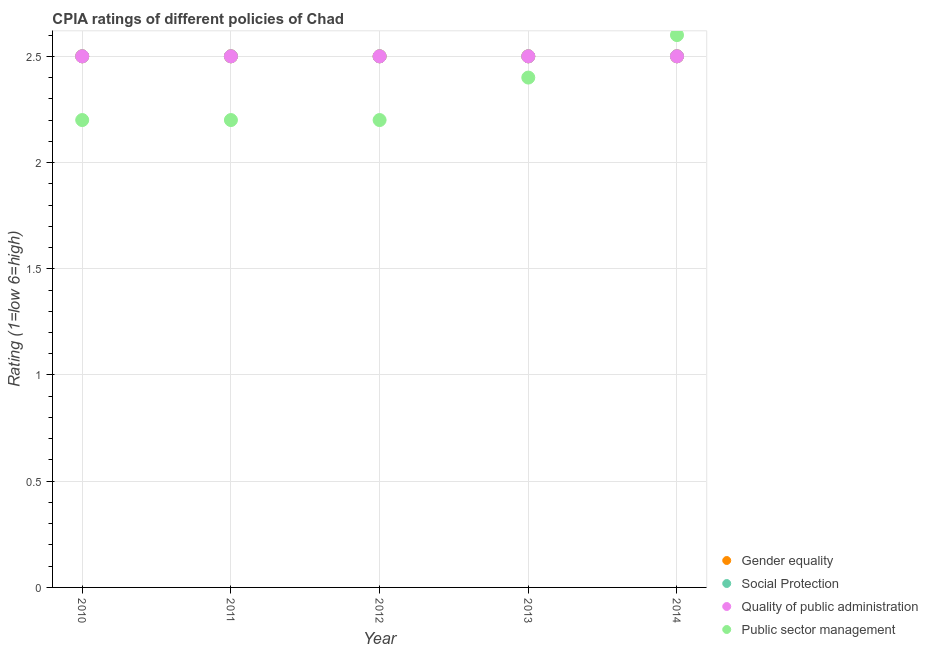How many different coloured dotlines are there?
Your response must be concise. 4. What is the cpia rating of gender equality in 2014?
Your response must be concise. 2.5. What is the total cpia rating of social protection in the graph?
Provide a short and direct response. 12.5. In how many years, is the cpia rating of gender equality greater than 1.4?
Provide a succinct answer. 5. Is the cpia rating of gender equality in 2012 less than that in 2013?
Offer a very short reply. No. Is the difference between the cpia rating of social protection in 2011 and 2013 greater than the difference between the cpia rating of quality of public administration in 2011 and 2013?
Your answer should be very brief. No. What is the difference between the highest and the lowest cpia rating of gender equality?
Offer a very short reply. 0. Is it the case that in every year, the sum of the cpia rating of quality of public administration and cpia rating of social protection is greater than the sum of cpia rating of gender equality and cpia rating of public sector management?
Your answer should be compact. No. Is the cpia rating of quality of public administration strictly greater than the cpia rating of gender equality over the years?
Your response must be concise. No. How many years are there in the graph?
Keep it short and to the point. 5. What is the difference between two consecutive major ticks on the Y-axis?
Provide a short and direct response. 0.5. Does the graph contain any zero values?
Your response must be concise. No. Does the graph contain grids?
Your answer should be very brief. Yes. Where does the legend appear in the graph?
Provide a short and direct response. Bottom right. What is the title of the graph?
Your answer should be very brief. CPIA ratings of different policies of Chad. Does "Management rating" appear as one of the legend labels in the graph?
Your answer should be very brief. No. What is the label or title of the X-axis?
Your answer should be compact. Year. What is the Rating (1=low 6=high) in Quality of public administration in 2010?
Make the answer very short. 2.5. What is the Rating (1=low 6=high) in Social Protection in 2011?
Ensure brevity in your answer.  2.5. What is the Rating (1=low 6=high) in Public sector management in 2011?
Offer a terse response. 2.2. What is the Rating (1=low 6=high) of Social Protection in 2012?
Your answer should be compact. 2.5. What is the Rating (1=low 6=high) of Public sector management in 2012?
Provide a short and direct response. 2.2. What is the Rating (1=low 6=high) of Quality of public administration in 2013?
Ensure brevity in your answer.  2.5. What is the Rating (1=low 6=high) of Public sector management in 2013?
Provide a short and direct response. 2.4. What is the Rating (1=low 6=high) in Social Protection in 2014?
Ensure brevity in your answer.  2.5. Across all years, what is the maximum Rating (1=low 6=high) in Social Protection?
Offer a terse response. 2.5. Across all years, what is the maximum Rating (1=low 6=high) in Quality of public administration?
Your response must be concise. 2.5. Across all years, what is the maximum Rating (1=low 6=high) in Public sector management?
Ensure brevity in your answer.  2.6. Across all years, what is the minimum Rating (1=low 6=high) in Public sector management?
Keep it short and to the point. 2.2. What is the total Rating (1=low 6=high) of Quality of public administration in the graph?
Provide a short and direct response. 12.5. What is the total Rating (1=low 6=high) of Public sector management in the graph?
Make the answer very short. 11.6. What is the difference between the Rating (1=low 6=high) of Gender equality in 2010 and that in 2011?
Keep it short and to the point. 0. What is the difference between the Rating (1=low 6=high) in Social Protection in 2010 and that in 2011?
Your answer should be very brief. 0. What is the difference between the Rating (1=low 6=high) of Quality of public administration in 2010 and that in 2011?
Your answer should be very brief. 0. What is the difference between the Rating (1=low 6=high) of Quality of public administration in 2010 and that in 2012?
Your answer should be compact. 0. What is the difference between the Rating (1=low 6=high) of Social Protection in 2010 and that in 2013?
Your answer should be very brief. 0. What is the difference between the Rating (1=low 6=high) in Quality of public administration in 2010 and that in 2013?
Give a very brief answer. 0. What is the difference between the Rating (1=low 6=high) of Social Protection in 2010 and that in 2014?
Offer a terse response. 0. What is the difference between the Rating (1=low 6=high) of Quality of public administration in 2010 and that in 2014?
Give a very brief answer. 0. What is the difference between the Rating (1=low 6=high) of Public sector management in 2010 and that in 2014?
Keep it short and to the point. -0.4. What is the difference between the Rating (1=low 6=high) of Gender equality in 2011 and that in 2012?
Your answer should be compact. 0. What is the difference between the Rating (1=low 6=high) of Social Protection in 2011 and that in 2012?
Offer a terse response. 0. What is the difference between the Rating (1=low 6=high) in Quality of public administration in 2011 and that in 2012?
Make the answer very short. 0. What is the difference between the Rating (1=low 6=high) of Gender equality in 2011 and that in 2013?
Your answer should be very brief. 0. What is the difference between the Rating (1=low 6=high) of Quality of public administration in 2011 and that in 2013?
Your answer should be compact. 0. What is the difference between the Rating (1=low 6=high) in Gender equality in 2011 and that in 2014?
Your answer should be compact. 0. What is the difference between the Rating (1=low 6=high) in Social Protection in 2011 and that in 2014?
Keep it short and to the point. 0. What is the difference between the Rating (1=low 6=high) of Gender equality in 2012 and that in 2013?
Keep it short and to the point. 0. What is the difference between the Rating (1=low 6=high) of Quality of public administration in 2012 and that in 2014?
Keep it short and to the point. 0. What is the difference between the Rating (1=low 6=high) of Public sector management in 2012 and that in 2014?
Offer a terse response. -0.4. What is the difference between the Rating (1=low 6=high) in Social Protection in 2013 and that in 2014?
Your response must be concise. 0. What is the difference between the Rating (1=low 6=high) in Quality of public administration in 2013 and that in 2014?
Provide a succinct answer. 0. What is the difference between the Rating (1=low 6=high) in Social Protection in 2010 and the Rating (1=low 6=high) in Quality of public administration in 2011?
Give a very brief answer. 0. What is the difference between the Rating (1=low 6=high) in Quality of public administration in 2010 and the Rating (1=low 6=high) in Public sector management in 2011?
Ensure brevity in your answer.  0.3. What is the difference between the Rating (1=low 6=high) of Gender equality in 2010 and the Rating (1=low 6=high) of Social Protection in 2012?
Give a very brief answer. 0. What is the difference between the Rating (1=low 6=high) in Social Protection in 2010 and the Rating (1=low 6=high) in Quality of public administration in 2012?
Provide a short and direct response. 0. What is the difference between the Rating (1=low 6=high) in Gender equality in 2010 and the Rating (1=low 6=high) in Social Protection in 2013?
Give a very brief answer. 0. What is the difference between the Rating (1=low 6=high) in Gender equality in 2010 and the Rating (1=low 6=high) in Quality of public administration in 2013?
Your response must be concise. 0. What is the difference between the Rating (1=low 6=high) of Social Protection in 2010 and the Rating (1=low 6=high) of Quality of public administration in 2013?
Give a very brief answer. 0. What is the difference between the Rating (1=low 6=high) in Gender equality in 2010 and the Rating (1=low 6=high) in Social Protection in 2014?
Your answer should be compact. 0. What is the difference between the Rating (1=low 6=high) of Gender equality in 2010 and the Rating (1=low 6=high) of Quality of public administration in 2014?
Your answer should be compact. 0. What is the difference between the Rating (1=low 6=high) in Social Protection in 2010 and the Rating (1=low 6=high) in Public sector management in 2014?
Offer a terse response. -0.1. What is the difference between the Rating (1=low 6=high) of Quality of public administration in 2010 and the Rating (1=low 6=high) of Public sector management in 2014?
Ensure brevity in your answer.  -0.1. What is the difference between the Rating (1=low 6=high) in Gender equality in 2011 and the Rating (1=low 6=high) in Quality of public administration in 2012?
Make the answer very short. 0. What is the difference between the Rating (1=low 6=high) in Social Protection in 2011 and the Rating (1=low 6=high) in Quality of public administration in 2012?
Offer a terse response. 0. What is the difference between the Rating (1=low 6=high) in Social Protection in 2011 and the Rating (1=low 6=high) in Public sector management in 2012?
Offer a terse response. 0.3. What is the difference between the Rating (1=low 6=high) of Quality of public administration in 2011 and the Rating (1=low 6=high) of Public sector management in 2012?
Make the answer very short. 0.3. What is the difference between the Rating (1=low 6=high) in Gender equality in 2011 and the Rating (1=low 6=high) in Quality of public administration in 2013?
Ensure brevity in your answer.  0. What is the difference between the Rating (1=low 6=high) in Gender equality in 2011 and the Rating (1=low 6=high) in Social Protection in 2014?
Make the answer very short. 0. What is the difference between the Rating (1=low 6=high) of Gender equality in 2011 and the Rating (1=low 6=high) of Quality of public administration in 2014?
Make the answer very short. 0. What is the difference between the Rating (1=low 6=high) in Social Protection in 2011 and the Rating (1=low 6=high) in Public sector management in 2014?
Ensure brevity in your answer.  -0.1. What is the difference between the Rating (1=low 6=high) of Gender equality in 2012 and the Rating (1=low 6=high) of Social Protection in 2013?
Your answer should be very brief. 0. What is the difference between the Rating (1=low 6=high) of Gender equality in 2012 and the Rating (1=low 6=high) of Quality of public administration in 2013?
Offer a terse response. 0. What is the difference between the Rating (1=low 6=high) in Social Protection in 2012 and the Rating (1=low 6=high) in Quality of public administration in 2013?
Offer a very short reply. 0. What is the difference between the Rating (1=low 6=high) of Quality of public administration in 2012 and the Rating (1=low 6=high) of Public sector management in 2013?
Offer a terse response. 0.1. What is the difference between the Rating (1=low 6=high) in Social Protection in 2012 and the Rating (1=low 6=high) in Quality of public administration in 2014?
Offer a very short reply. 0. What is the difference between the Rating (1=low 6=high) in Social Protection in 2012 and the Rating (1=low 6=high) in Public sector management in 2014?
Give a very brief answer. -0.1. What is the difference between the Rating (1=low 6=high) in Quality of public administration in 2012 and the Rating (1=low 6=high) in Public sector management in 2014?
Give a very brief answer. -0.1. What is the difference between the Rating (1=low 6=high) of Social Protection in 2013 and the Rating (1=low 6=high) of Quality of public administration in 2014?
Offer a terse response. 0. What is the average Rating (1=low 6=high) in Social Protection per year?
Make the answer very short. 2.5. What is the average Rating (1=low 6=high) in Quality of public administration per year?
Make the answer very short. 2.5. What is the average Rating (1=low 6=high) of Public sector management per year?
Offer a very short reply. 2.32. In the year 2010, what is the difference between the Rating (1=low 6=high) in Gender equality and Rating (1=low 6=high) in Quality of public administration?
Give a very brief answer. 0. In the year 2010, what is the difference between the Rating (1=low 6=high) of Gender equality and Rating (1=low 6=high) of Public sector management?
Your response must be concise. 0.3. In the year 2010, what is the difference between the Rating (1=low 6=high) in Social Protection and Rating (1=low 6=high) in Public sector management?
Give a very brief answer. 0.3. In the year 2010, what is the difference between the Rating (1=low 6=high) of Quality of public administration and Rating (1=low 6=high) of Public sector management?
Make the answer very short. 0.3. In the year 2011, what is the difference between the Rating (1=low 6=high) of Gender equality and Rating (1=low 6=high) of Social Protection?
Provide a short and direct response. 0. In the year 2011, what is the difference between the Rating (1=low 6=high) in Gender equality and Rating (1=low 6=high) in Quality of public administration?
Provide a short and direct response. 0. In the year 2011, what is the difference between the Rating (1=low 6=high) of Social Protection and Rating (1=low 6=high) of Quality of public administration?
Offer a terse response. 0. In the year 2011, what is the difference between the Rating (1=low 6=high) in Social Protection and Rating (1=low 6=high) in Public sector management?
Your answer should be very brief. 0.3. In the year 2011, what is the difference between the Rating (1=low 6=high) in Quality of public administration and Rating (1=low 6=high) in Public sector management?
Provide a succinct answer. 0.3. In the year 2012, what is the difference between the Rating (1=low 6=high) in Gender equality and Rating (1=low 6=high) in Social Protection?
Offer a very short reply. 0. In the year 2012, what is the difference between the Rating (1=low 6=high) of Gender equality and Rating (1=low 6=high) of Quality of public administration?
Provide a short and direct response. 0. In the year 2012, what is the difference between the Rating (1=low 6=high) in Social Protection and Rating (1=low 6=high) in Quality of public administration?
Keep it short and to the point. 0. In the year 2012, what is the difference between the Rating (1=low 6=high) of Social Protection and Rating (1=low 6=high) of Public sector management?
Provide a succinct answer. 0.3. In the year 2013, what is the difference between the Rating (1=low 6=high) in Gender equality and Rating (1=low 6=high) in Social Protection?
Give a very brief answer. 0. In the year 2013, what is the difference between the Rating (1=low 6=high) in Gender equality and Rating (1=low 6=high) in Quality of public administration?
Provide a short and direct response. 0. In the year 2013, what is the difference between the Rating (1=low 6=high) in Social Protection and Rating (1=low 6=high) in Public sector management?
Provide a short and direct response. 0.1. In the year 2014, what is the difference between the Rating (1=low 6=high) in Gender equality and Rating (1=low 6=high) in Quality of public administration?
Provide a short and direct response. 0. In the year 2014, what is the difference between the Rating (1=low 6=high) in Gender equality and Rating (1=low 6=high) in Public sector management?
Keep it short and to the point. -0.1. In the year 2014, what is the difference between the Rating (1=low 6=high) in Social Protection and Rating (1=low 6=high) in Public sector management?
Your answer should be compact. -0.1. In the year 2014, what is the difference between the Rating (1=low 6=high) in Quality of public administration and Rating (1=low 6=high) in Public sector management?
Your response must be concise. -0.1. What is the ratio of the Rating (1=low 6=high) of Social Protection in 2010 to that in 2012?
Provide a succinct answer. 1. What is the ratio of the Rating (1=low 6=high) of Social Protection in 2010 to that in 2013?
Provide a succinct answer. 1. What is the ratio of the Rating (1=low 6=high) in Quality of public administration in 2010 to that in 2013?
Provide a succinct answer. 1. What is the ratio of the Rating (1=low 6=high) of Social Protection in 2010 to that in 2014?
Provide a succinct answer. 1. What is the ratio of the Rating (1=low 6=high) of Public sector management in 2010 to that in 2014?
Keep it short and to the point. 0.85. What is the ratio of the Rating (1=low 6=high) in Gender equality in 2011 to that in 2012?
Keep it short and to the point. 1. What is the ratio of the Rating (1=low 6=high) of Quality of public administration in 2011 to that in 2012?
Your answer should be compact. 1. What is the ratio of the Rating (1=low 6=high) of Gender equality in 2011 to that in 2013?
Keep it short and to the point. 1. What is the ratio of the Rating (1=low 6=high) in Public sector management in 2011 to that in 2013?
Provide a short and direct response. 0.92. What is the ratio of the Rating (1=low 6=high) of Public sector management in 2011 to that in 2014?
Offer a very short reply. 0.85. What is the ratio of the Rating (1=low 6=high) of Social Protection in 2012 to that in 2013?
Your response must be concise. 1. What is the ratio of the Rating (1=low 6=high) of Public sector management in 2012 to that in 2013?
Keep it short and to the point. 0.92. What is the ratio of the Rating (1=low 6=high) in Gender equality in 2012 to that in 2014?
Your response must be concise. 1. What is the ratio of the Rating (1=low 6=high) of Social Protection in 2012 to that in 2014?
Your response must be concise. 1. What is the ratio of the Rating (1=low 6=high) in Public sector management in 2012 to that in 2014?
Your answer should be very brief. 0.85. What is the ratio of the Rating (1=low 6=high) of Social Protection in 2013 to that in 2014?
Offer a very short reply. 1. What is the difference between the highest and the second highest Rating (1=low 6=high) in Gender equality?
Your answer should be very brief. 0. What is the difference between the highest and the second highest Rating (1=low 6=high) in Public sector management?
Provide a short and direct response. 0.2. What is the difference between the highest and the lowest Rating (1=low 6=high) in Gender equality?
Your answer should be compact. 0. What is the difference between the highest and the lowest Rating (1=low 6=high) of Public sector management?
Give a very brief answer. 0.4. 